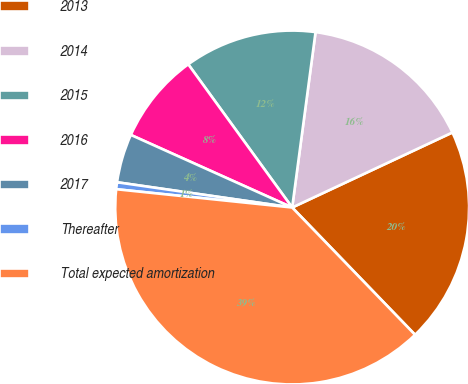<chart> <loc_0><loc_0><loc_500><loc_500><pie_chart><fcel>2013<fcel>2014<fcel>2015<fcel>2016<fcel>2017<fcel>Thereafter<fcel>Total expected amortization<nl><fcel>19.75%<fcel>15.92%<fcel>12.1%<fcel>8.28%<fcel>4.45%<fcel>0.63%<fcel>38.87%<nl></chart> 